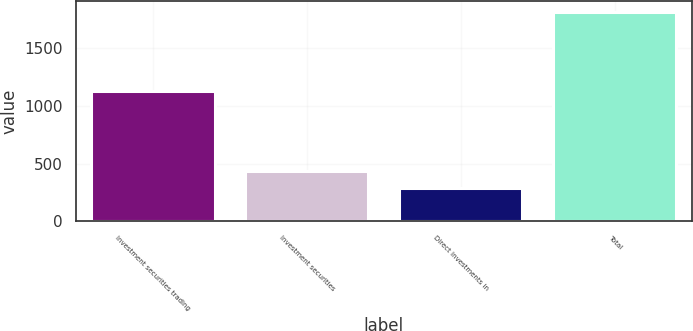Convert chart. <chart><loc_0><loc_0><loc_500><loc_500><bar_chart><fcel>Investment securities trading<fcel>Investment securities<fcel>Direct investments in<fcel>Total<nl><fcel>1126.1<fcel>437.49<fcel>284.7<fcel>1812.6<nl></chart> 